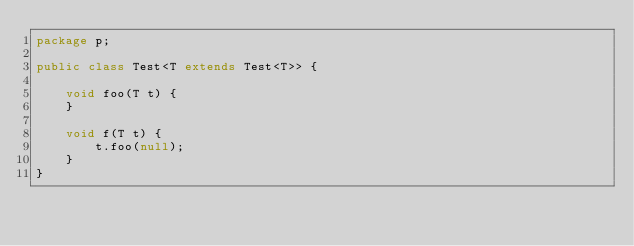Convert code to text. <code><loc_0><loc_0><loc_500><loc_500><_Java_>package p;

public class Test<T extends Test<T>> {

    void foo(T t) {
    }

    void f(T t) {
        t.foo(null);
    }
}
</code> 